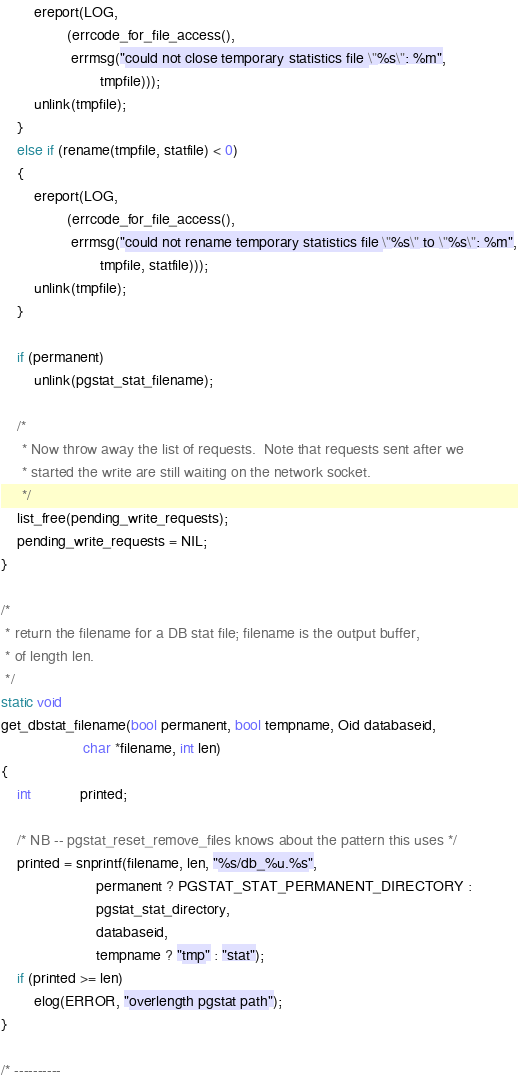Convert code to text. <code><loc_0><loc_0><loc_500><loc_500><_C_>		ereport(LOG,
				(errcode_for_file_access(),
				 errmsg("could not close temporary statistics file \"%s\": %m",
						tmpfile)));
		unlink(tmpfile);
	}
	else if (rename(tmpfile, statfile) < 0)
	{
		ereport(LOG,
				(errcode_for_file_access(),
				 errmsg("could not rename temporary statistics file \"%s\" to \"%s\": %m",
						tmpfile, statfile)));
		unlink(tmpfile);
	}

	if (permanent)
		unlink(pgstat_stat_filename);

	/*
	 * Now throw away the list of requests.  Note that requests sent after we
	 * started the write are still waiting on the network socket.
	 */
	list_free(pending_write_requests);
	pending_write_requests = NIL;
}

/*
 * return the filename for a DB stat file; filename is the output buffer,
 * of length len.
 */
static void
get_dbstat_filename(bool permanent, bool tempname, Oid databaseid,
					char *filename, int len)
{
	int			printed;

	/* NB -- pgstat_reset_remove_files knows about the pattern this uses */
	printed = snprintf(filename, len, "%s/db_%u.%s",
					   permanent ? PGSTAT_STAT_PERMANENT_DIRECTORY :
					   pgstat_stat_directory,
					   databaseid,
					   tempname ? "tmp" : "stat");
	if (printed >= len)
		elog(ERROR, "overlength pgstat path");
}

/* ----------</code> 